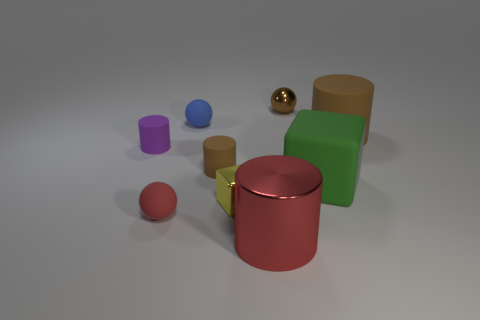The other matte cylinder that is the same color as the big matte cylinder is what size?
Your response must be concise. Small. What is the shape of the tiny matte thing that is the same color as the shiny cylinder?
Your response must be concise. Sphere. How many cylinders are either small red things or tiny blue objects?
Provide a short and direct response. 0. The shiny object that is the same size as the yellow cube is what color?
Provide a short and direct response. Brown. What number of objects are both to the left of the tiny brown metal sphere and behind the small yellow object?
Your answer should be compact. 3. What is the large red thing made of?
Provide a succinct answer. Metal. How many things are either large cyan metal cubes or brown objects?
Your answer should be very brief. 3. There is a yellow metallic object in front of the small blue ball; does it have the same size as the brown rubber cylinder right of the small brown ball?
Your answer should be compact. No. What number of other objects are the same size as the brown metallic thing?
Offer a very short reply. 5. How many objects are rubber balls that are in front of the purple cylinder or cylinders behind the red matte sphere?
Keep it short and to the point. 4. 